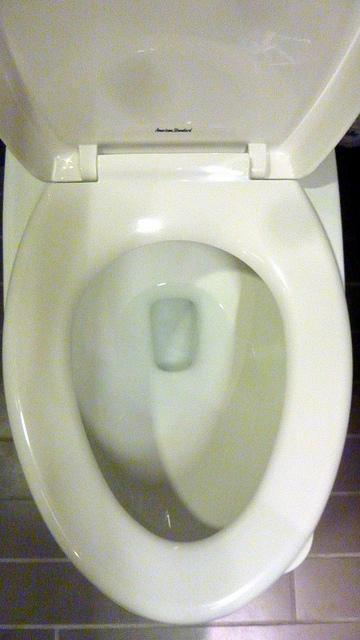How many people are in the water?
Give a very brief answer. 0. 